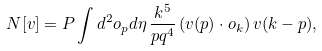Convert formula to latex. <formula><loc_0><loc_0><loc_500><loc_500>N [ v ] = P \int d ^ { 2 } o _ { p } d \eta \, \frac { k ^ { 5 } } { p q ^ { 4 } } \, ( v ( p ) \cdot o _ { k } ) \, v ( k - p ) ,</formula> 